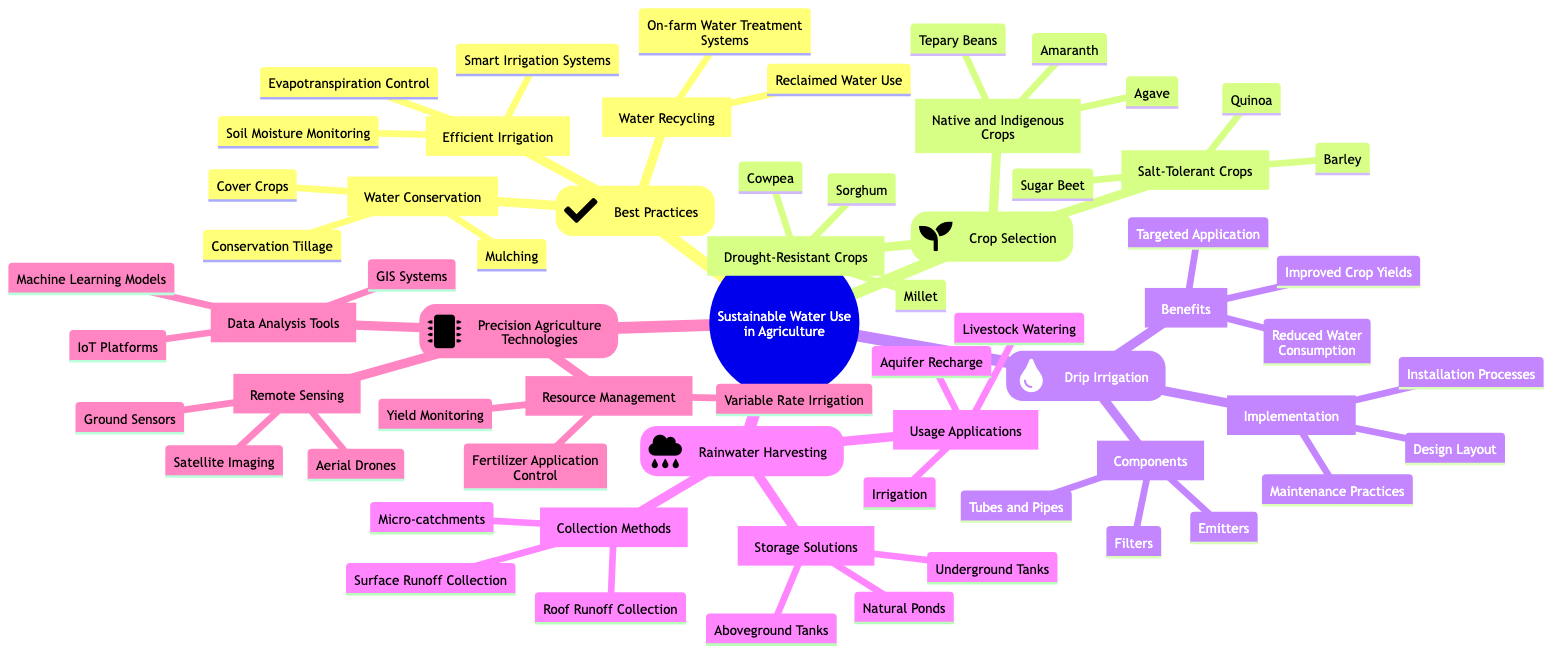What are the three best practices listed under Sustainable Water Use in Agriculture? The diagram lists "Efficient Irrigation," "Water Conservation," and "Water Recycling" as the three best practices under Sustainable Water Use in Agriculture.
Answer: Efficient Irrigation, Water Conservation, Water Recycling How many types of drought-resistant crops are mentioned? Under the crop selection category, there are three types specifically listed as drought-resistant crops: "Sorghum," "Millet," and "Cowpea."
Answer: 3 What is one benefit of drip irrigation? The diagram highlights several benefits of drip irrigation, one of which is "Reduced Water Consumption."
Answer: Reduced Water Consumption What are the storage solutions for rainwater harvesting? The diagram specifies three storage solutions for rainwater harvesting: "Underground Tanks," "Aboveground Tanks," and "Natural Ponds."
Answer: Underground Tanks, Aboveground Tanks, Natural Ponds Which precision agriculture technology uses satellite imaging? "Remote Sensing," which is a part of precision agriculture technologies, includes "Satellite Imaging" as one of its elements.
Answer: Remote Sensing What is one application of harvested rainwater? The diagram shows "Irrigation" as one of the applications for harvested rainwater.
Answer: Irrigation What are two components of drip irrigation? The diagram mentions "Emitters" and "Tubes and Pipes" as components of drip irrigation.
Answer: Emitters, Tubes and Pipes How do data analysis tools in precision agriculture contribute to resource management? The diagram indicates that data analysis tools like "GIS Systems" and "Machine Learning Models" support resource management by optimizing practices like "Variable Rate Irrigation" and "Fertilizer Application Control."
Answer: By optimizing practices like Variable Rate Irrigation and Fertilizer Application Control What methods are included for collecting rainwater? The diagram lists three methods for collecting rainwater: "Roof Runoff Collection," "Surface Runoff Collection," and "Micro-catchments."
Answer: Roof Runoff Collection, Surface Runoff Collection, Micro-catchments 